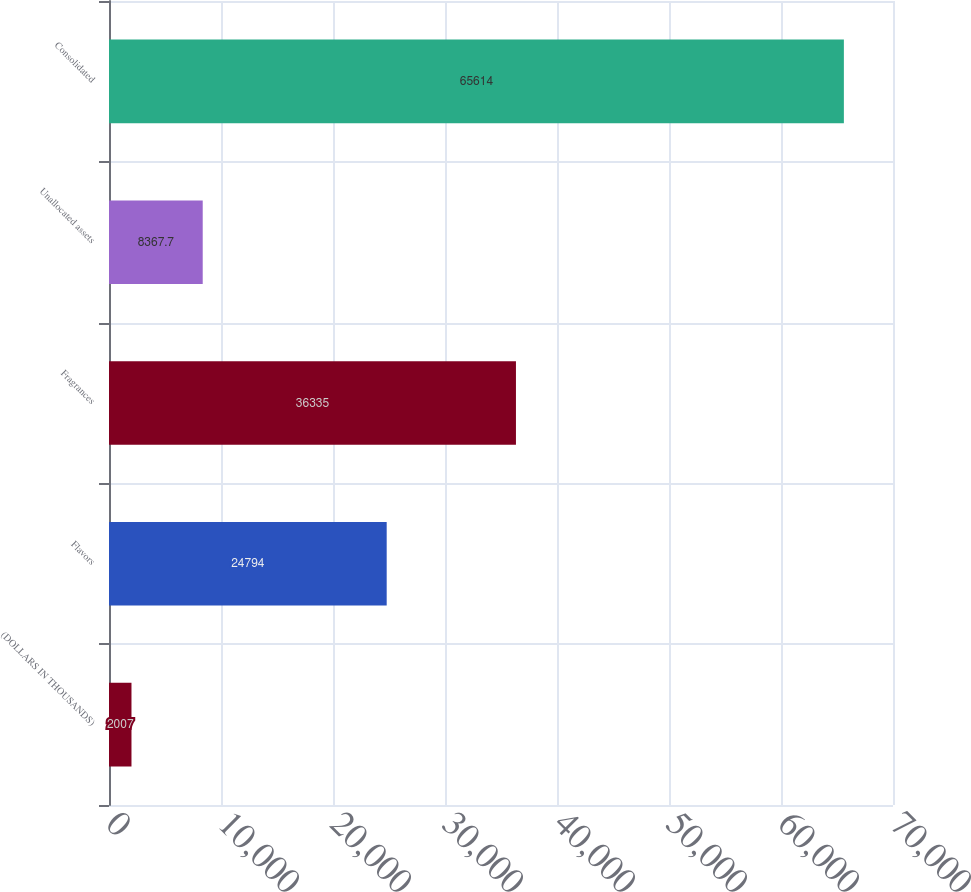<chart> <loc_0><loc_0><loc_500><loc_500><bar_chart><fcel>(DOLLARS IN THOUSANDS)<fcel>Flavors<fcel>Fragrances<fcel>Unallocated assets<fcel>Consolidated<nl><fcel>2007<fcel>24794<fcel>36335<fcel>8367.7<fcel>65614<nl></chart> 